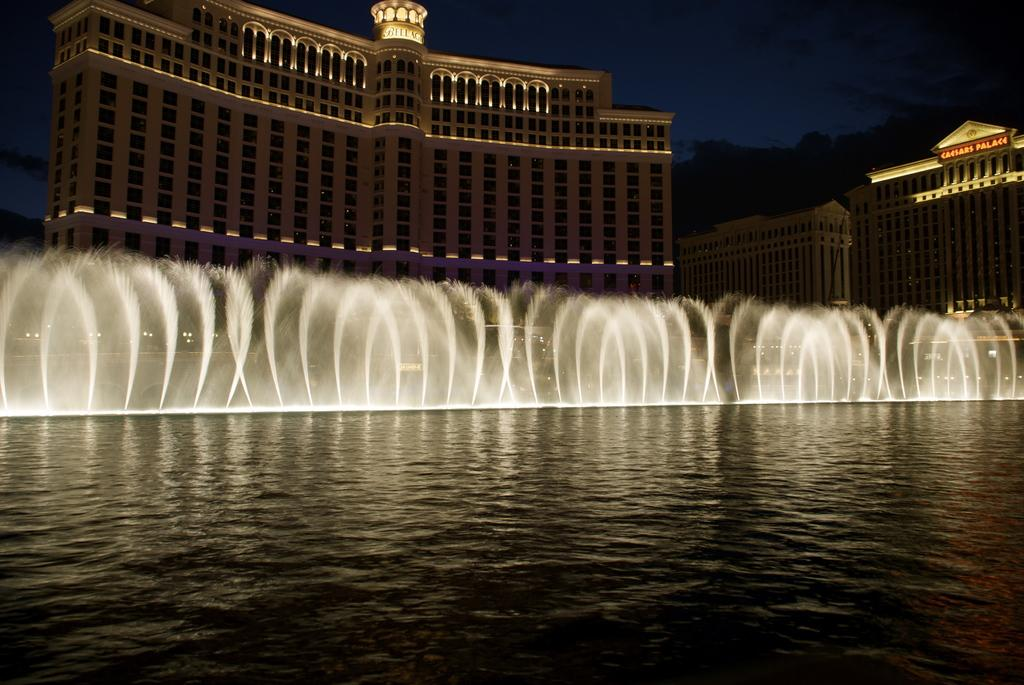What is the main feature of the image? The main feature of the image is a water surface. Are there any other objects or structures near the water surface? Yes, there is a fountain in the image, far away from the water surface. What can be seen in the background of the image? In the background of the image, there are buildings and the sky visible. What type of lipstick is being used by the fountain in the image? There is no lipstick or any indication of makeup in the image; it features a water surface and a fountain. 